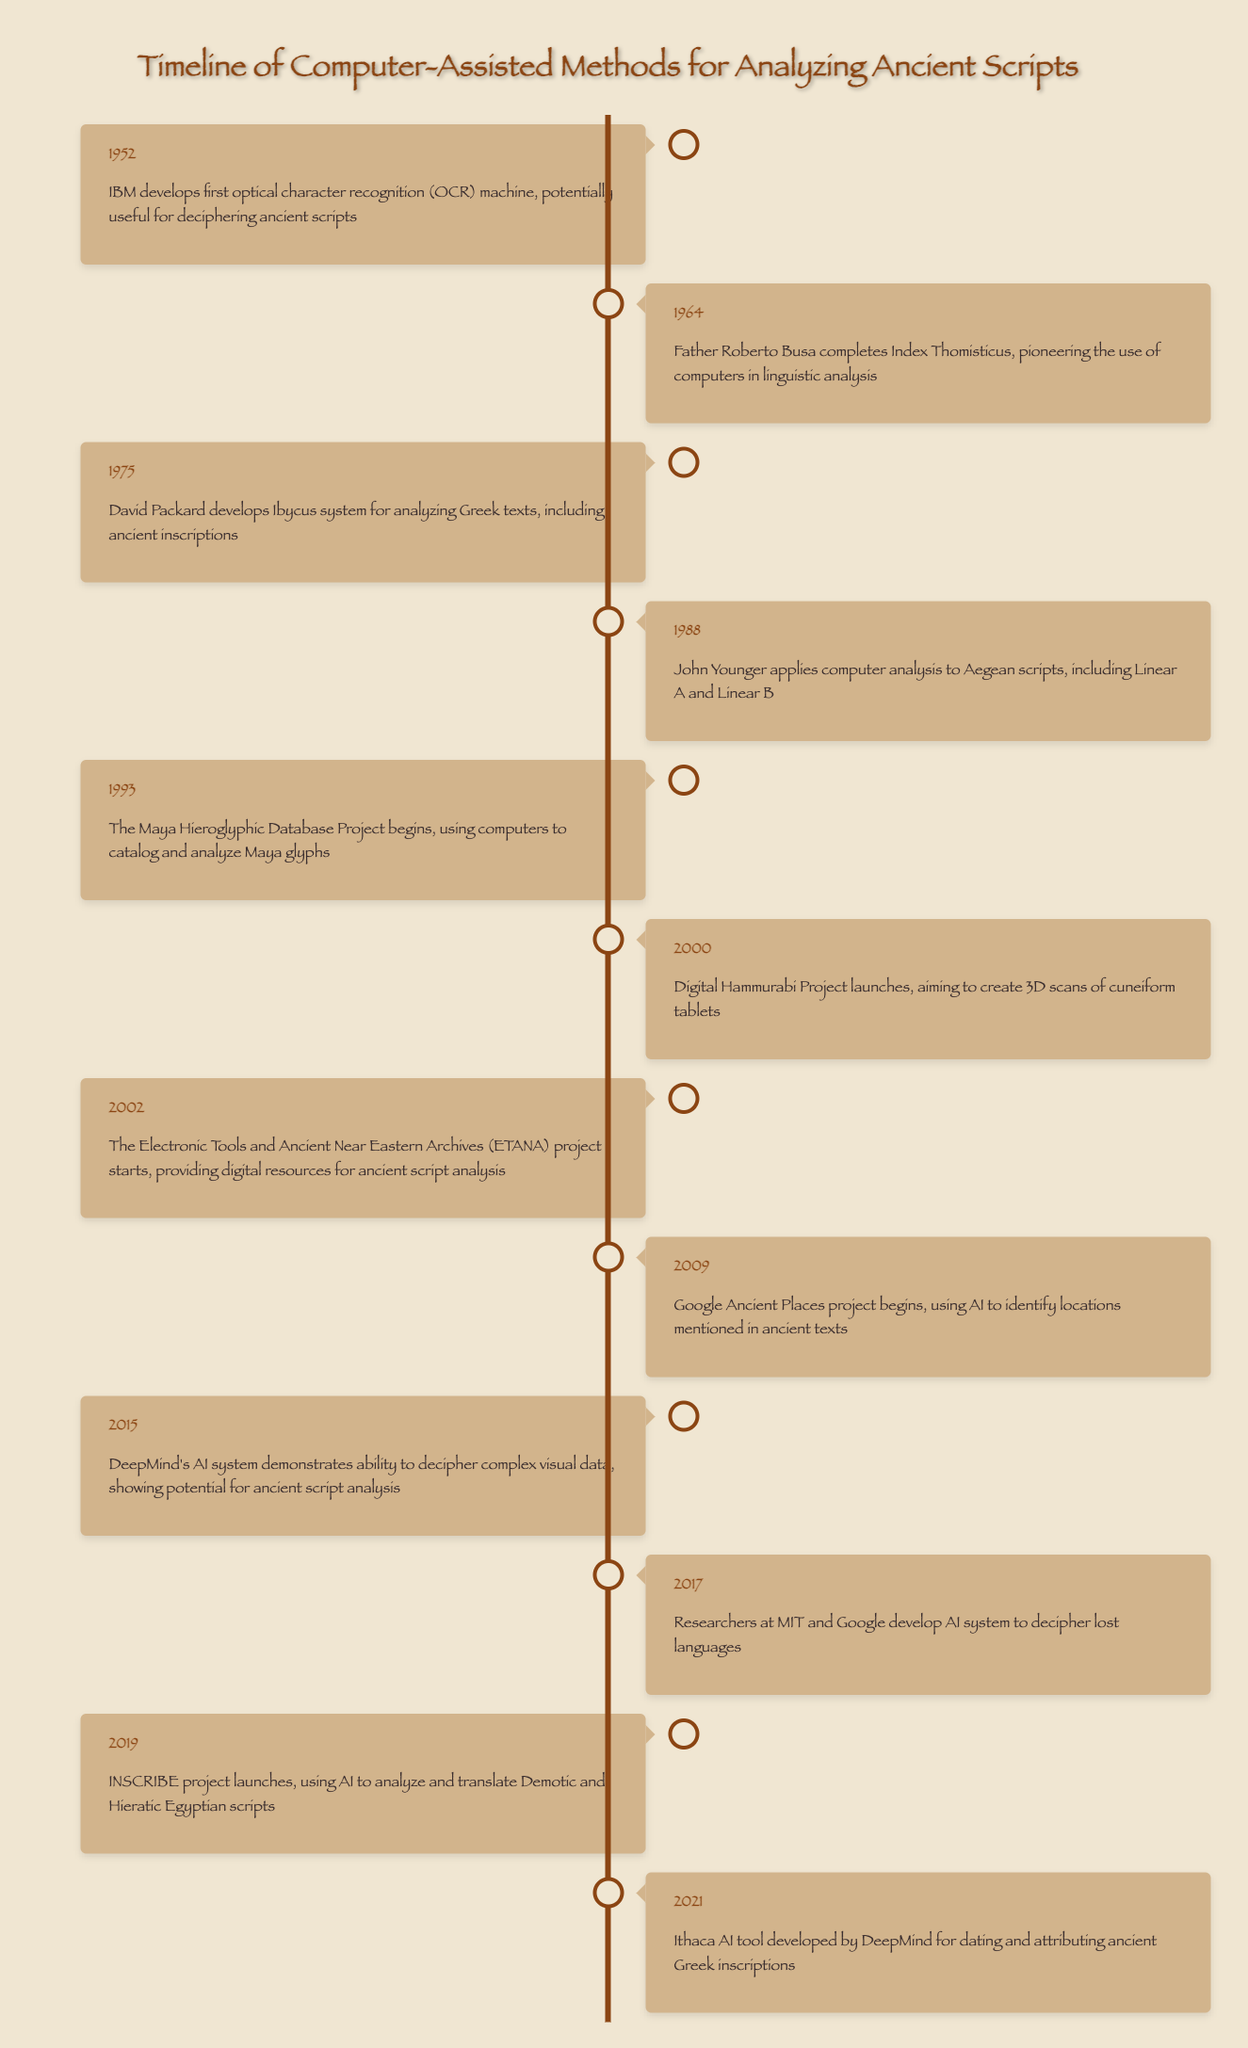What year did the IBM develop the first OCR machine? Referring to the timeline, the event states that in 1952, IBM developed the first optical character recognition (OCR) machine.
Answer: 1952 Who completed the Index Thomisticus in 1964? According to the timeline, the event in 1964 credits Father Roberto Busa with completing the Index Thomisticus.
Answer: Father Roberto Busa What is the earliest project mentioned that utilizes AI for analyzing ancient texts? By checking the timeline, the Google Ancient Places project started in 2009, which is the earliest mention of an AI application in analyzing ancient scripts.
Answer: 2009 List the projects that were launched in the 2000s. The timeline indicates the following projects were launched in the 2000s: the Digital Hammurabi Project in 2000, the ETANA project in 2002, and the Google Ancient Places project in 2009.
Answer: Digital Hammurabi Project (2000), ETANA (2002), Google Ancient Places (2009) How many years are between the launch of the Maya Hieroglyphic Database Project and the Ithaca AI tool development? The Maya Hieroglyphic Database Project began in 1993 and the Ithaca AI tool was developed in 2021. The difference is 2021 - 1993 = 28 years.
Answer: 28 years Did any projects involve deciphering lost languages? Yes, the timeline indicates that in 2017, researchers at MIT and Google developed an AI system to decipher lost languages.
Answer: Yes What event took place in 1988? The timeline shows that in 1988, John Younger applied computer analysis to Aegean scripts, including Linear A and Linear B.
Answer: John Younger applies computer analysis to Aegean scripts Compare the years of the first OCR machine development and the Ibycus system release. What is the difference? The OCR machine was developed in 1952 and the Ibycus system was developed in 1975. Therefore, the difference is 1975 - 1952 = 23 years.
Answer: 23 years Which projects were focused on analyzing Egyptian scripts? According to the timeline, the INSCRIBE project in 2019 specifically focuses on analyzing and translating Demotic and Hieratic Egyptian scripts.
Answer: INSCRIBE project (2019) 